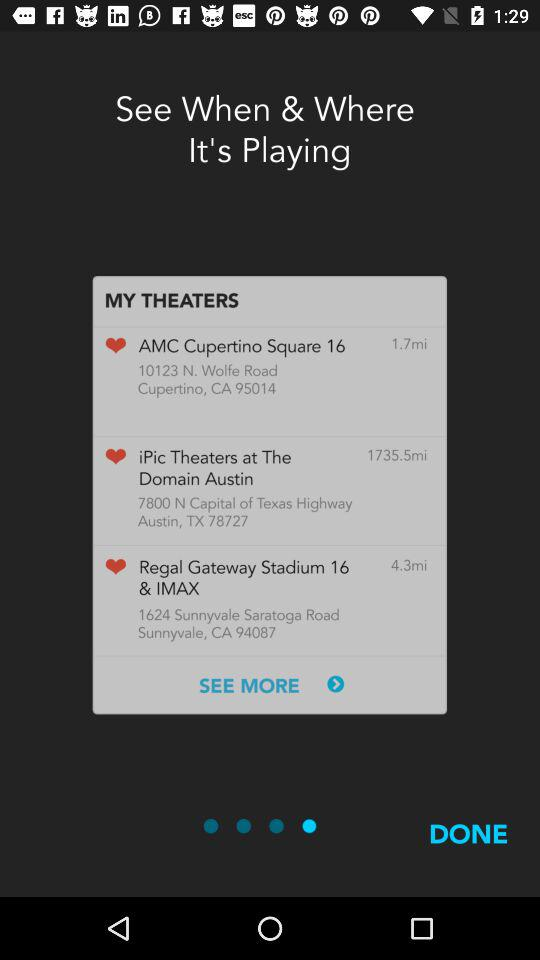How many theaters are in my theaters?
Answer the question using a single word or phrase. 3 